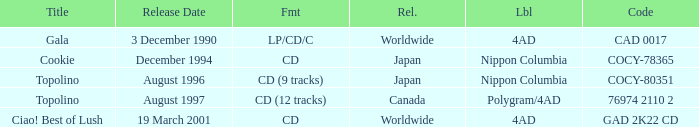When was Gala released? Worldwide. Give me the full table as a dictionary. {'header': ['Title', 'Release Date', 'Fmt', 'Rel.', 'Lbl', 'Code'], 'rows': [['Gala', '3 December 1990', 'LP/CD/C', 'Worldwide', '4AD', 'CAD 0017'], ['Cookie', 'December 1994', 'CD', 'Japan', 'Nippon Columbia', 'COCY-78365'], ['Topolino', 'August 1996', 'CD (9 tracks)', 'Japan', 'Nippon Columbia', 'COCY-80351'], ['Topolino', 'August 1997', 'CD (12 tracks)', 'Canada', 'Polygram/4AD', '76974 2110 2'], ['Ciao! Best of Lush', '19 March 2001', 'CD', 'Worldwide', '4AD', 'GAD 2K22 CD']]} 